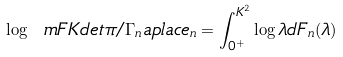Convert formula to latex. <formula><loc_0><loc_0><loc_500><loc_500>\log \ m F K d e t { \pi / \Gamma _ { n } } \L a p l a c e _ { n } = \int _ { 0 ^ { + } } ^ { K ^ { 2 } } \log \lambda d F _ { n } ( \lambda )</formula> 